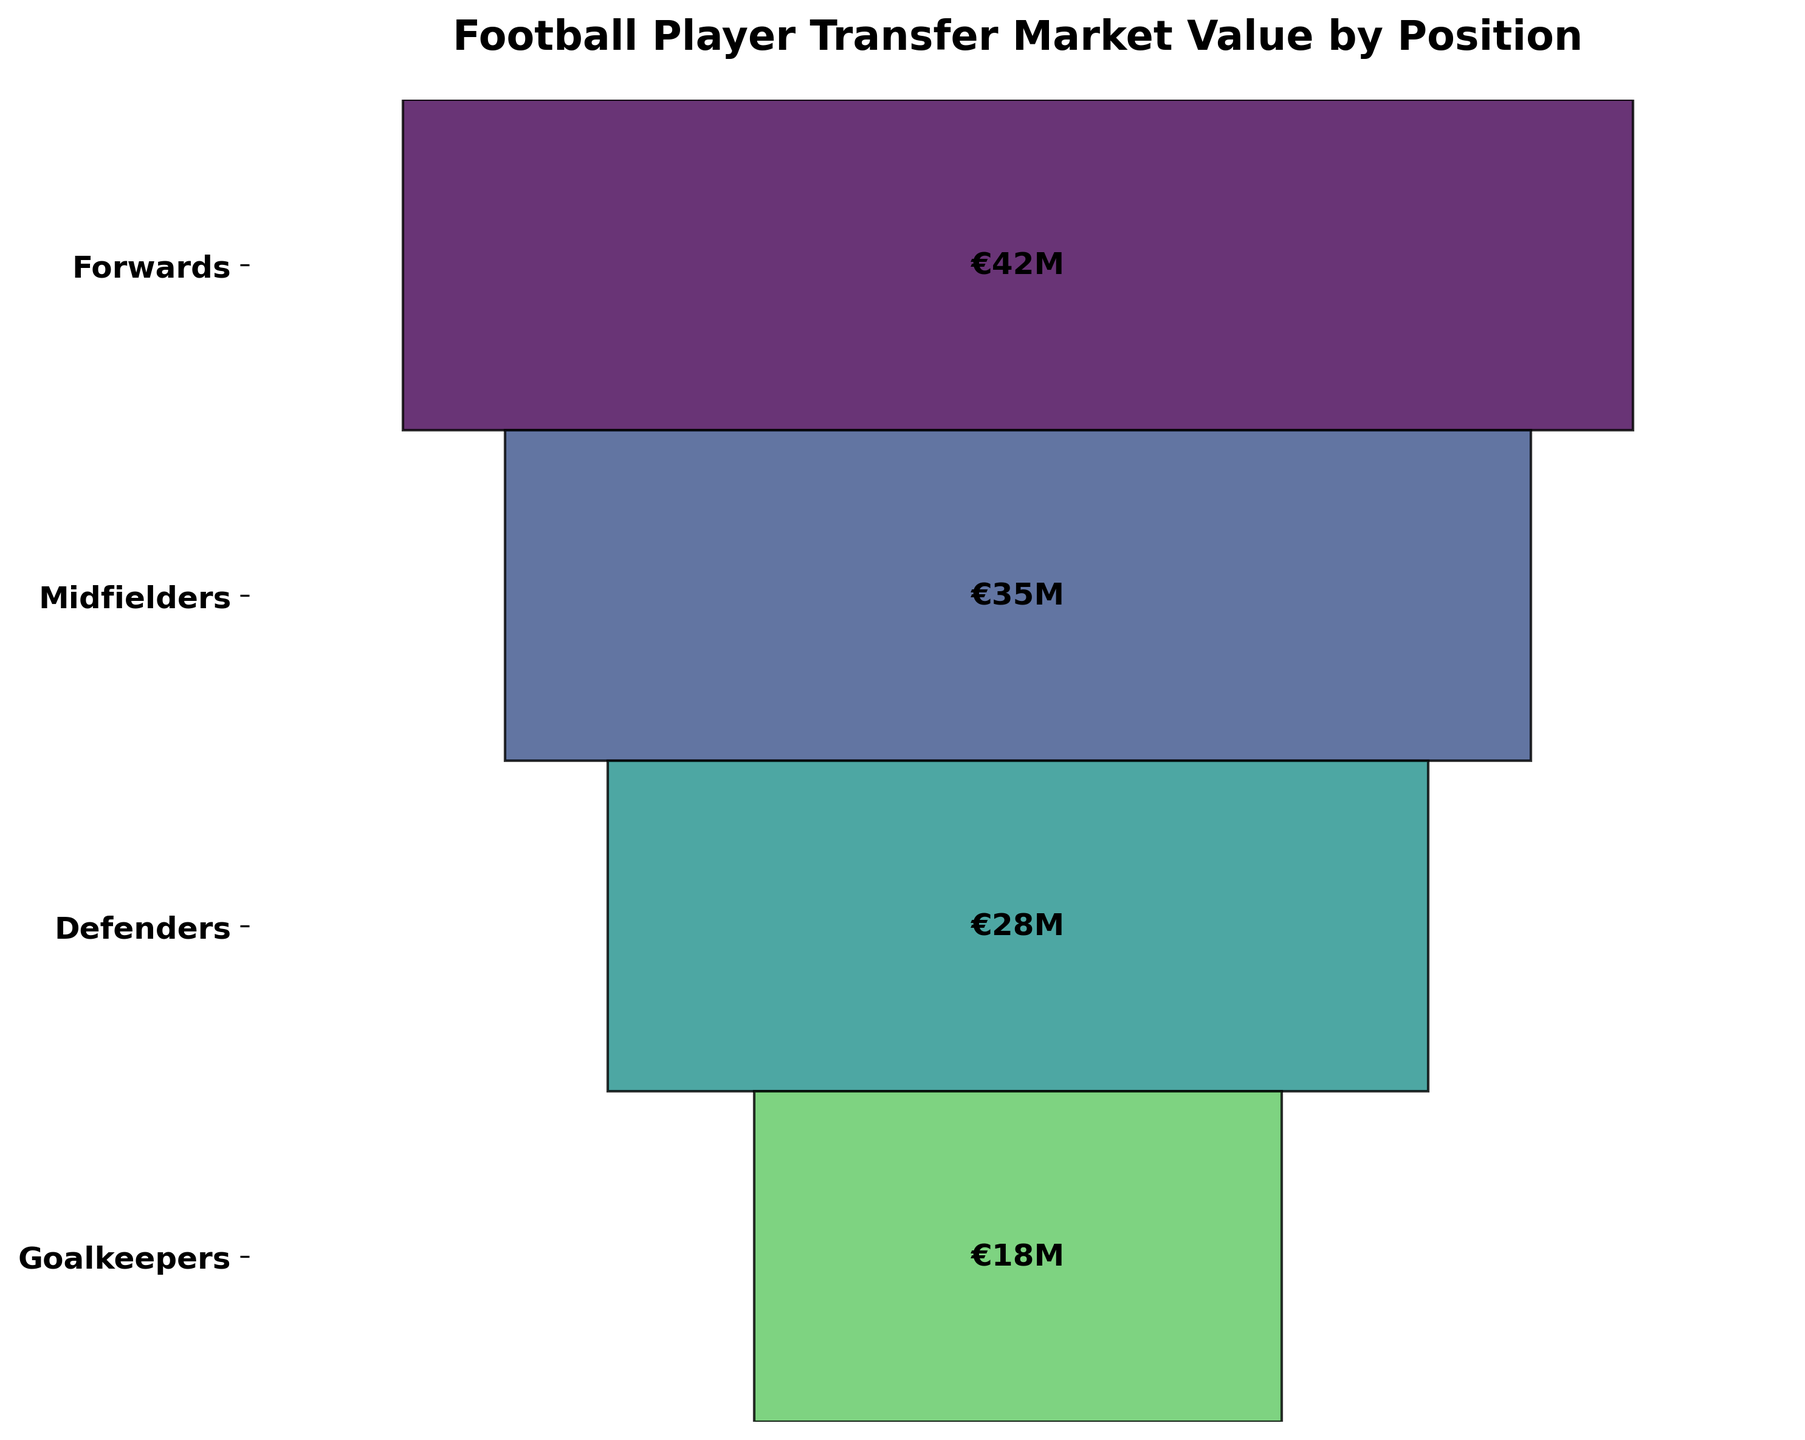What is the title of the chart? The title is located at the top of the chart and reads, 'Football Player Transfer Market Value by Position'.
Answer: Football Player Transfer Market Value by Position Which position has the highest average transfer value? From the visual distribution of the chart, the segment corresponding to Forwards is at the top and is the widest on the funnel chart, indicating the highest average transfer value.
Answer: Forwards What is the average transfer value for Defenders? The segment labeled 'Defenders' shows an internal text displaying the specific average transfer value.
Answer: €28M Which position has the lowest average transfer value? The narrowest segment at the bottom of the funnel chart represents Goalkeepers, indicating the lowest average transfer value.
Answer: Goalkeepers By how much does the average transfer value of Forwards exceed that of Goalkeepers? The difference can be found by subtracting the average transfer value of Goalkeepers (€18M) from that of Forwards (€42M). Calculation: 42 - 18 = 24.
Answer: €24M How does the average transfer value of Midfielders compare to that of Defenders? Comparing the internal values, Midfielders have an average transfer value of €35M, while Defenders have €28M.
Answer: Midfielders have a higher value by €7M What is the total average transfer value if you sum all the positions? Adding up the values of all positions: Forwards (€42M) + Midfielders (€35M) + Defenders (€28M) + Goalkeepers (€18M) = 123M.
Answer: €123M Which positions have an average transfer value above €25M? The positions with values above €25M are Forwards (€42M), Midfielders (€35M), and Defenders (€28M).
Answer: Forwards, Midfielders, Defenders What percentage of the highest average transfer value is the value of Goalkeepers? To find the percentage, divide the value for Goalkeepers (€18M) by the highest value (€42M) and multiply by 100. Calculation: (18 / 42) * 100 ≈ 42.86%.
Answer: 42.86% What is the difference in average transfer values between the second highest and the lowest positions? The second highest average transfer value is for Midfielders (€35M) and the lowest is for Goalkeepers (€18M). The difference is found by subtracting the latter from the former. Calculation: 35 - 18 = 17.
Answer: €17M 